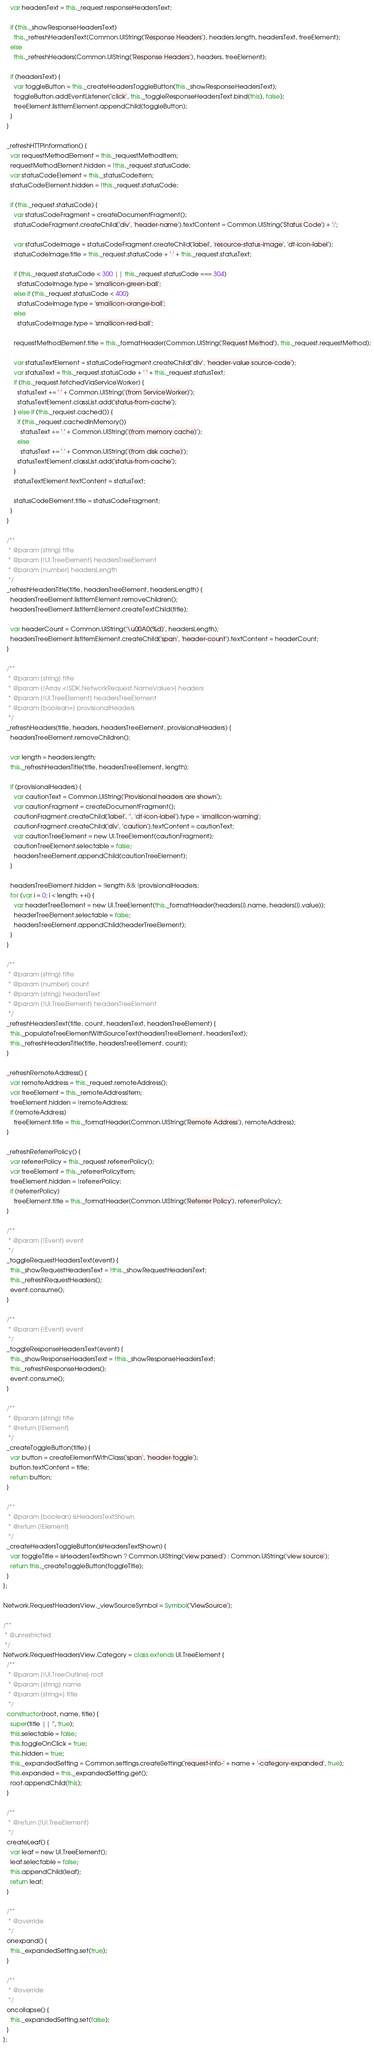Convert code to text. <code><loc_0><loc_0><loc_500><loc_500><_JavaScript_>    var headersText = this._request.responseHeadersText;

    if (this._showResponseHeadersText)
      this._refreshHeadersText(Common.UIString('Response Headers'), headers.length, headersText, treeElement);
    else
      this._refreshHeaders(Common.UIString('Response Headers'), headers, treeElement);

    if (headersText) {
      var toggleButton = this._createHeadersToggleButton(this._showResponseHeadersText);
      toggleButton.addEventListener('click', this._toggleResponseHeadersText.bind(this), false);
      treeElement.listItemElement.appendChild(toggleButton);
    }
  }

  _refreshHTTPInformation() {
    var requestMethodElement = this._requestMethodItem;
    requestMethodElement.hidden = !this._request.statusCode;
    var statusCodeElement = this._statusCodeItem;
    statusCodeElement.hidden = !this._request.statusCode;

    if (this._request.statusCode) {
      var statusCodeFragment = createDocumentFragment();
      statusCodeFragment.createChild('div', 'header-name').textContent = Common.UIString('Status Code') + ':';

      var statusCodeImage = statusCodeFragment.createChild('label', 'resource-status-image', 'dt-icon-label');
      statusCodeImage.title = this._request.statusCode + ' ' + this._request.statusText;

      if (this._request.statusCode < 300 || this._request.statusCode === 304)
        statusCodeImage.type = 'smallicon-green-ball';
      else if (this._request.statusCode < 400)
        statusCodeImage.type = 'smallicon-orange-ball';
      else
        statusCodeImage.type = 'smallicon-red-ball';

      requestMethodElement.title = this._formatHeader(Common.UIString('Request Method'), this._request.requestMethod);

      var statusTextElement = statusCodeFragment.createChild('div', 'header-value source-code');
      var statusText = this._request.statusCode + ' ' + this._request.statusText;
      if (this._request.fetchedViaServiceWorker) {
        statusText += ' ' + Common.UIString('(from ServiceWorker)');
        statusTextElement.classList.add('status-from-cache');
      } else if (this._request.cached()) {
        if (this._request.cachedInMemory())
          statusText += ' ' + Common.UIString('(from memory cache)');
        else
          statusText += ' ' + Common.UIString('(from disk cache)');
        statusTextElement.classList.add('status-from-cache');
      }
      statusTextElement.textContent = statusText;

      statusCodeElement.title = statusCodeFragment;
    }
  }

  /**
   * @param {string} title
   * @param {!UI.TreeElement} headersTreeElement
   * @param {number} headersLength
   */
  _refreshHeadersTitle(title, headersTreeElement, headersLength) {
    headersTreeElement.listItemElement.removeChildren();
    headersTreeElement.listItemElement.createTextChild(title);

    var headerCount = Common.UIString('\u00A0(%d)', headersLength);
    headersTreeElement.listItemElement.createChild('span', 'header-count').textContent = headerCount;
  }

  /**
   * @param {string} title
   * @param {!Array.<!SDK.NetworkRequest.NameValue>} headers
   * @param {!UI.TreeElement} headersTreeElement
   * @param {boolean=} provisionalHeaders
   */
  _refreshHeaders(title, headers, headersTreeElement, provisionalHeaders) {
    headersTreeElement.removeChildren();

    var length = headers.length;
    this._refreshHeadersTitle(title, headersTreeElement, length);

    if (provisionalHeaders) {
      var cautionText = Common.UIString('Provisional headers are shown');
      var cautionFragment = createDocumentFragment();
      cautionFragment.createChild('label', '', 'dt-icon-label').type = 'smallicon-warning';
      cautionFragment.createChild('div', 'caution').textContent = cautionText;
      var cautionTreeElement = new UI.TreeElement(cautionFragment);
      cautionTreeElement.selectable = false;
      headersTreeElement.appendChild(cautionTreeElement);
    }

    headersTreeElement.hidden = !length && !provisionalHeaders;
    for (var i = 0; i < length; ++i) {
      var headerTreeElement = new UI.TreeElement(this._formatHeader(headers[i].name, headers[i].value));
      headerTreeElement.selectable = false;
      headersTreeElement.appendChild(headerTreeElement);
    }
  }

  /**
   * @param {string} title
   * @param {number} count
   * @param {string} headersText
   * @param {!UI.TreeElement} headersTreeElement
   */
  _refreshHeadersText(title, count, headersText, headersTreeElement) {
    this._populateTreeElementWithSourceText(headersTreeElement, headersText);
    this._refreshHeadersTitle(title, headersTreeElement, count);
  }

  _refreshRemoteAddress() {
    var remoteAddress = this._request.remoteAddress();
    var treeElement = this._remoteAddressItem;
    treeElement.hidden = !remoteAddress;
    if (remoteAddress)
      treeElement.title = this._formatHeader(Common.UIString('Remote Address'), remoteAddress);
  }

  _refreshReferrerPolicy() {
    var referrerPolicy = this._request.referrerPolicy();
    var treeElement = this._referrerPolicyItem;
    treeElement.hidden = !referrerPolicy;
    if (referrerPolicy)
      treeElement.title = this._formatHeader(Common.UIString('Referrer Policy'), referrerPolicy);
  }

  /**
   * @param {!Event} event
   */
  _toggleRequestHeadersText(event) {
    this._showRequestHeadersText = !this._showRequestHeadersText;
    this._refreshRequestHeaders();
    event.consume();
  }

  /**
   * @param {!Event} event
   */
  _toggleResponseHeadersText(event) {
    this._showResponseHeadersText = !this._showResponseHeadersText;
    this._refreshResponseHeaders();
    event.consume();
  }

  /**
   * @param {string} title
   * @return {!Element}
   */
  _createToggleButton(title) {
    var button = createElementWithClass('span', 'header-toggle');
    button.textContent = title;
    return button;
  }

  /**
   * @param {boolean} isHeadersTextShown
   * @return {!Element}
   */
  _createHeadersToggleButton(isHeadersTextShown) {
    var toggleTitle = isHeadersTextShown ? Common.UIString('view parsed') : Common.UIString('view source');
    return this._createToggleButton(toggleTitle);
  }
};

Network.RequestHeadersView._viewSourceSymbol = Symbol('ViewSource');

/**
 * @unrestricted
 */
Network.RequestHeadersView.Category = class extends UI.TreeElement {
  /**
   * @param {!UI.TreeOutline} root
   * @param {string} name
   * @param {string=} title
   */
  constructor(root, name, title) {
    super(title || '', true);
    this.selectable = false;
    this.toggleOnClick = true;
    this.hidden = true;
    this._expandedSetting = Common.settings.createSetting('request-info-' + name + '-category-expanded', true);
    this.expanded = this._expandedSetting.get();
    root.appendChild(this);
  }

  /**
   * @return {!UI.TreeElement}
   */
  createLeaf() {
    var leaf = new UI.TreeElement();
    leaf.selectable = false;
    this.appendChild(leaf);
    return leaf;
  }

  /**
   * @override
   */
  onexpand() {
    this._expandedSetting.set(true);
  }

  /**
   * @override
   */
  oncollapse() {
    this._expandedSetting.set(false);
  }
};
</code> 